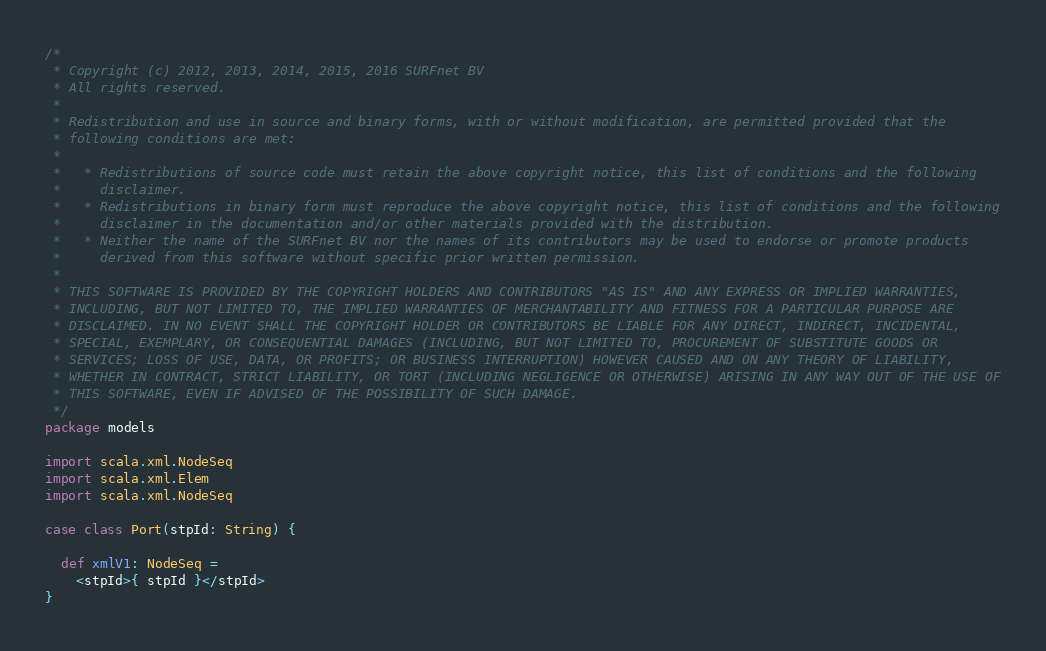Convert code to text. <code><loc_0><loc_0><loc_500><loc_500><_Scala_>/*
 * Copyright (c) 2012, 2013, 2014, 2015, 2016 SURFnet BV
 * All rights reserved.
 *
 * Redistribution and use in source and binary forms, with or without modification, are permitted provided that the
 * following conditions are met:
 *
 *   * Redistributions of source code must retain the above copyright notice, this list of conditions and the following
 *     disclaimer.
 *   * Redistributions in binary form must reproduce the above copyright notice, this list of conditions and the following
 *     disclaimer in the documentation and/or other materials provided with the distribution.
 *   * Neither the name of the SURFnet BV nor the names of its contributors may be used to endorse or promote products
 *     derived from this software without specific prior written permission.
 *
 * THIS SOFTWARE IS PROVIDED BY THE COPYRIGHT HOLDERS AND CONTRIBUTORS "AS IS" AND ANY EXPRESS OR IMPLIED WARRANTIES,
 * INCLUDING, BUT NOT LIMITED TO, THE IMPLIED WARRANTIES OF MERCHANTABILITY AND FITNESS FOR A PARTICULAR PURPOSE ARE
 * DISCLAIMED. IN NO EVENT SHALL THE COPYRIGHT HOLDER OR CONTRIBUTORS BE LIABLE FOR ANY DIRECT, INDIRECT, INCIDENTAL,
 * SPECIAL, EXEMPLARY, OR CONSEQUENTIAL DAMAGES (INCLUDING, BUT NOT LIMITED TO, PROCUREMENT OF SUBSTITUTE GOODS OR
 * SERVICES; LOSS OF USE, DATA, OR PROFITS; OR BUSINESS INTERRUPTION) HOWEVER CAUSED AND ON ANY THEORY OF LIABILITY,
 * WHETHER IN CONTRACT, STRICT LIABILITY, OR TORT (INCLUDING NEGLIGENCE OR OTHERWISE) ARISING IN ANY WAY OUT OF THE USE OF
 * THIS SOFTWARE, EVEN IF ADVISED OF THE POSSIBILITY OF SUCH DAMAGE.
 */
package models

import scala.xml.NodeSeq
import scala.xml.Elem
import scala.xml.NodeSeq

case class Port(stpId: String) {

  def xmlV1: NodeSeq =
    <stpId>{ stpId }</stpId>
}
</code> 